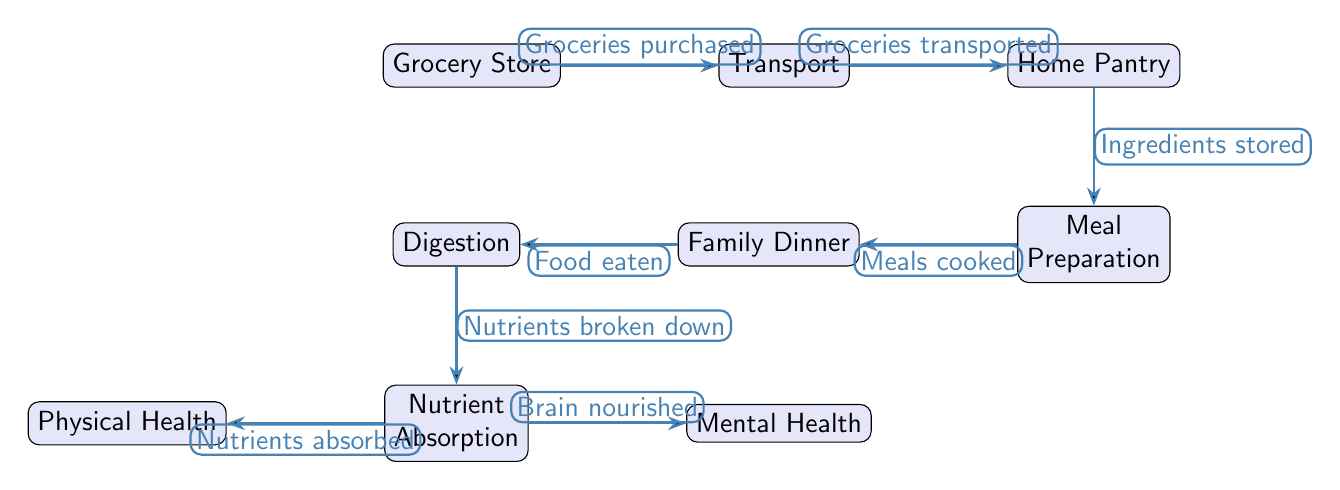What is the first node in the flow? The first node in the flow, as per the diagram, is the grocery store, where the process begins with purchasing groceries.
Answer: Grocery Store How many nodes are present in the diagram? By counting all the distinct nodes in the diagram, including the grocery store, transport, home pantry, meal preparation, family dinner, digestion, nutrient absorption, physical health, and mental health, we find there are eight nodes.
Answer: Eight What happens after groceries are transported? After groceries are transported, the next step is that the ingredients are stored in the home pantry. This is indicated as the relationship flowing from the transport node to the home pantry node.
Answer: Ingredients stored What influences mental health in the food chain? In the diagram, nutrient absorption directly influences mental health, as it is a process through which the brain is nourished. This is shown by the edge connecting nutrient absorption to mental health.
Answer: Brain nourished What is the last step before reaching physical health? The last step before reaching physical health is that nutrients are absorbed. This flow indicates that the absorption of nutrients is crucial for overall physical health.
Answer: Nutrients absorbed Which two nodes are connected directly after the family dinner? After family dinner, the direct connection is to the digestion node, indicating that food eaten leads to the digestion process.
Answer: Digestion What role do the groceries play in the meal preparation step? The groceries are critical in meal preparation because they are the ingredients stored in the home pantry, which are utilized to prepare meals according to the flow outlined in the diagram.
Answer: Ingredients stored What health aspect is associated with nutrient absorption? Nutrient absorption is associated with both physical health and mental health, as indicated by the edges leading to both health aspects from the nutrient absorption node.
Answer: Physical Health, Mental Health 